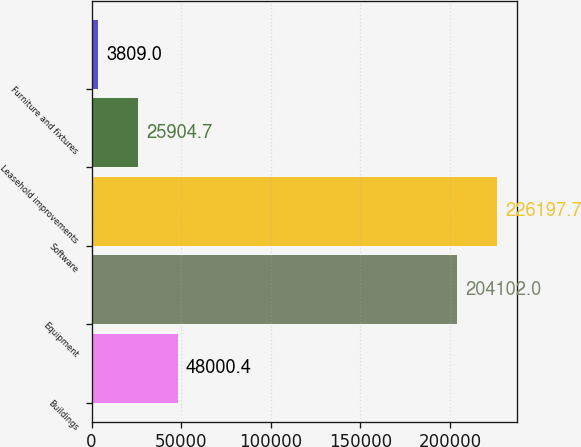<chart> <loc_0><loc_0><loc_500><loc_500><bar_chart><fcel>Buildings<fcel>Equipment<fcel>Software<fcel>Leasehold improvements<fcel>Furniture and fixtures<nl><fcel>48000.4<fcel>204102<fcel>226198<fcel>25904.7<fcel>3809<nl></chart> 